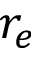<formula> <loc_0><loc_0><loc_500><loc_500>r _ { e }</formula> 